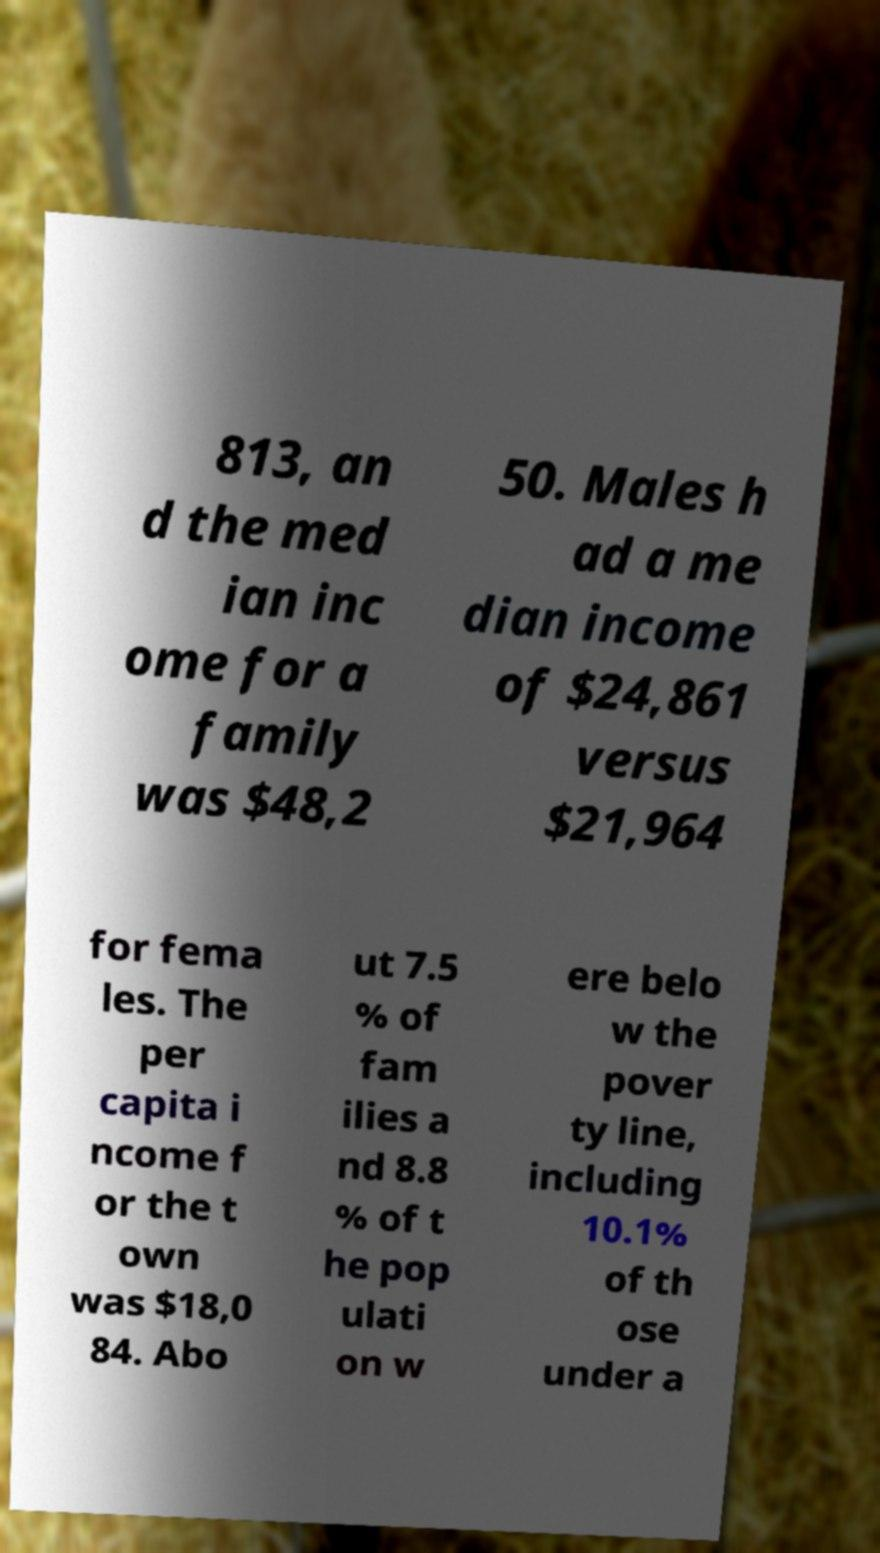There's text embedded in this image that I need extracted. Can you transcribe it verbatim? 813, an d the med ian inc ome for a family was $48,2 50. Males h ad a me dian income of $24,861 versus $21,964 for fema les. The per capita i ncome f or the t own was $18,0 84. Abo ut 7.5 % of fam ilies a nd 8.8 % of t he pop ulati on w ere belo w the pover ty line, including 10.1% of th ose under a 